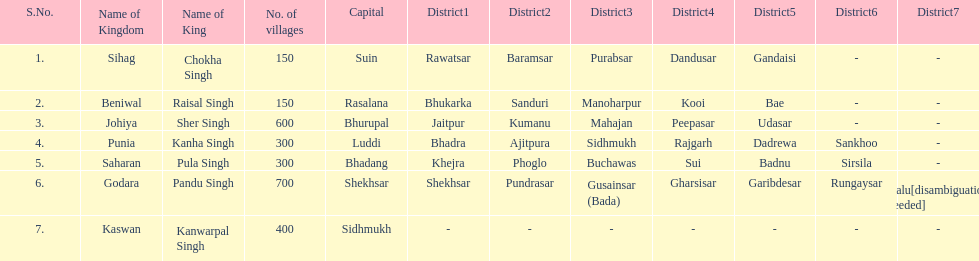What are the number of villages johiya has according to this chart? 600. 